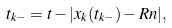<formula> <loc_0><loc_0><loc_500><loc_500>t _ { k - } = t - | x _ { k } ( t _ { k - } ) - R n | ,</formula> 